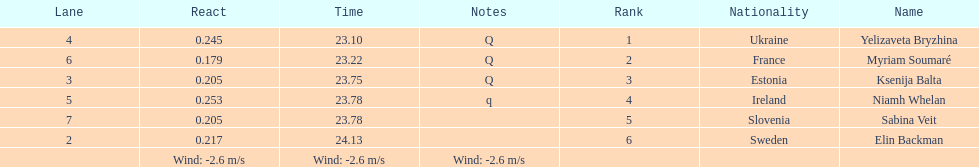I'm looking to parse the entire table for insights. Could you assist me with that? {'header': ['Lane', 'React', 'Time', 'Notes', 'Rank', 'Nationality', 'Name'], 'rows': [['4', '0.245', '23.10', 'Q', '1', 'Ukraine', 'Yelizaveta Bryzhina'], ['6', '0.179', '23.22', 'Q', '2', 'France', 'Myriam Soumaré'], ['3', '0.205', '23.75', 'Q', '3', 'Estonia', 'Ksenija Balta'], ['5', '0.253', '23.78', 'q', '4', 'Ireland', 'Niamh Whelan'], ['7', '0.205', '23.78', '', '5', 'Slovenia', 'Sabina Veit'], ['2', '0.217', '24.13', '', '6', 'Sweden', 'Elin Backman'], ['', 'Wind: -2.6\xa0m/s', 'Wind: -2.6\xa0m/s', 'Wind: -2.6\xa0m/s', '', '', '']]} Are any of the lanes in consecutive order? No. 